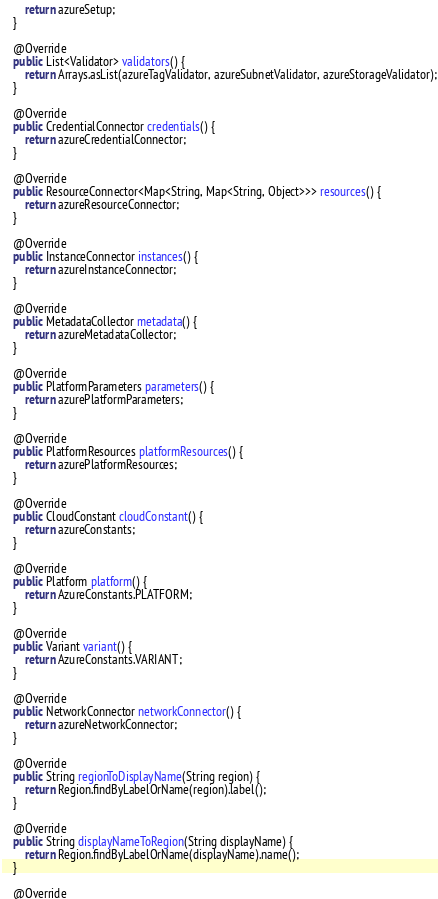Convert code to text. <code><loc_0><loc_0><loc_500><loc_500><_Java_>        return azureSetup;
    }

    @Override
    public List<Validator> validators() {
        return Arrays.asList(azureTagValidator, azureSubnetValidator, azureStorageValidator);
    }

    @Override
    public CredentialConnector credentials() {
        return azureCredentialConnector;
    }

    @Override
    public ResourceConnector<Map<String, Map<String, Object>>> resources() {
        return azureResourceConnector;
    }

    @Override
    public InstanceConnector instances() {
        return azureInstanceConnector;
    }

    @Override
    public MetadataCollector metadata() {
        return azureMetadataCollector;
    }

    @Override
    public PlatformParameters parameters() {
        return azurePlatformParameters;
    }

    @Override
    public PlatformResources platformResources() {
        return azurePlatformResources;
    }

    @Override
    public CloudConstant cloudConstant() {
        return azureConstants;
    }

    @Override
    public Platform platform() {
        return AzureConstants.PLATFORM;
    }

    @Override
    public Variant variant() {
        return AzureConstants.VARIANT;
    }

    @Override
    public NetworkConnector networkConnector() {
        return azureNetworkConnector;
    }

    @Override
    public String regionToDisplayName(String region) {
        return Region.findByLabelOrName(region).label();
    }

    @Override
    public String displayNameToRegion(String displayName) {
        return Region.findByLabelOrName(displayName).name();
    }

    @Override</code> 